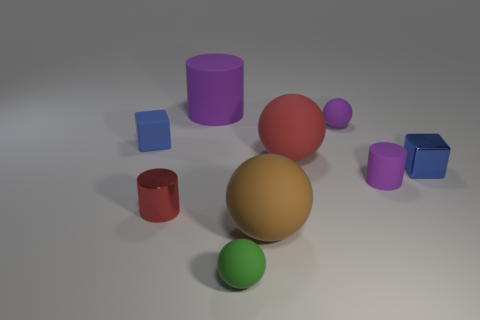Subtract 1 balls. How many balls are left? 3 Add 1 red matte blocks. How many objects exist? 10 Subtract all cylinders. How many objects are left? 6 Subtract all matte objects. Subtract all small blue objects. How many objects are left? 0 Add 1 large brown things. How many large brown things are left? 2 Add 6 green objects. How many green objects exist? 7 Subtract 2 blue blocks. How many objects are left? 7 